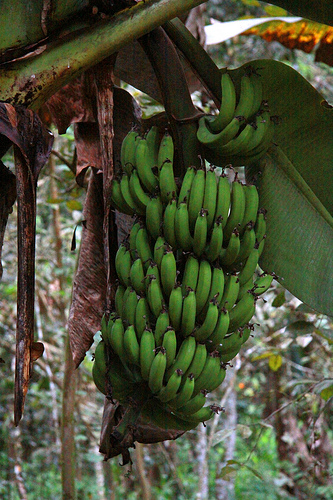Please provide a short description for this region: [0.65, 0.35, 0.68, 0.47]. In this area, there is a green banana. 